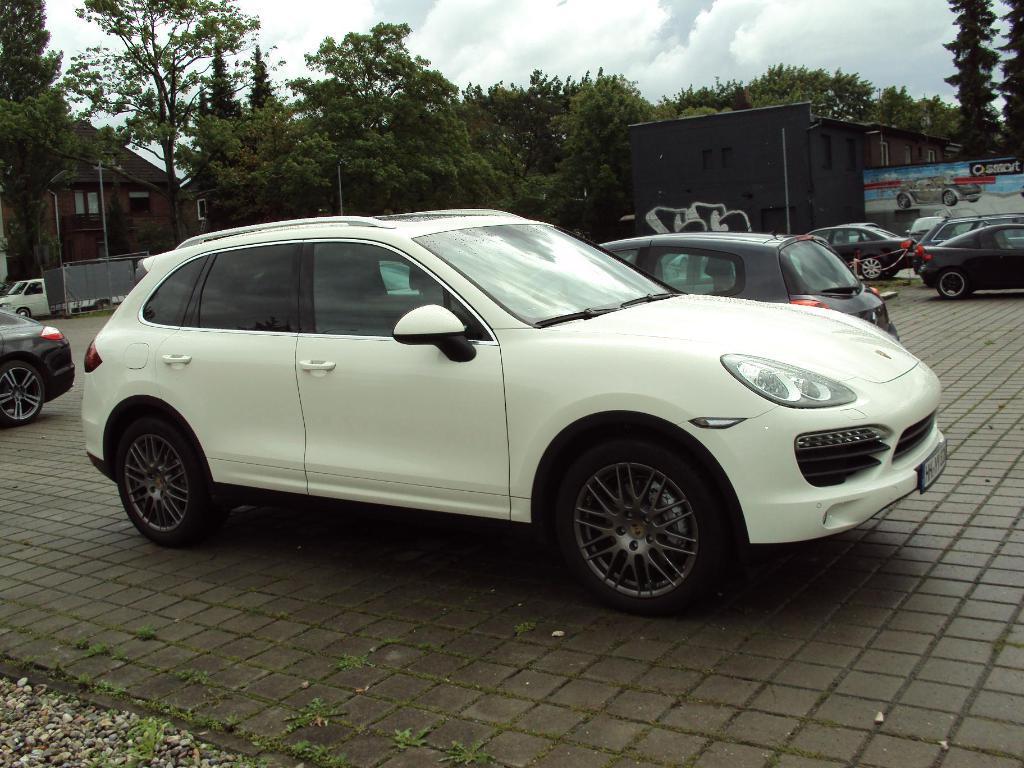How would you summarize this image in a sentence or two? Here we can see cars. There are poles, trees, hoarding, and houses. In the background there is sky with clouds. 